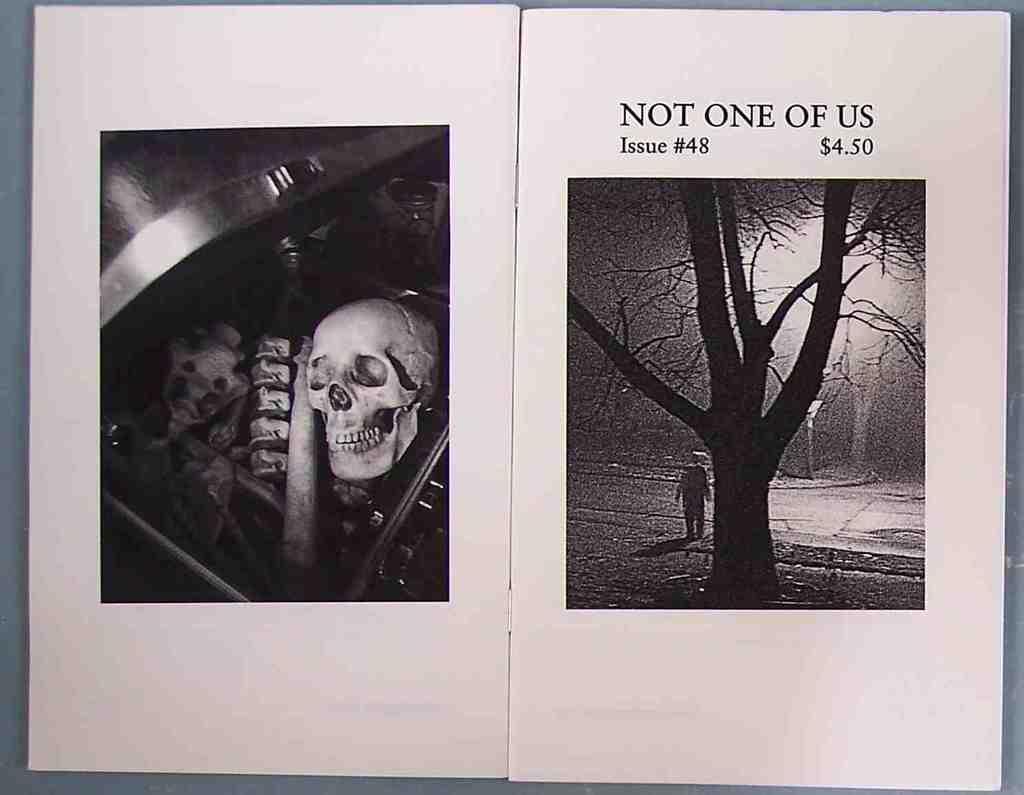How would you summarize this image in a sentence or two? In this image we can see a book. On the left side of the image we can see skull and few more things are kept in the box. On the right side of the image we can see a person, tree and some text here. 